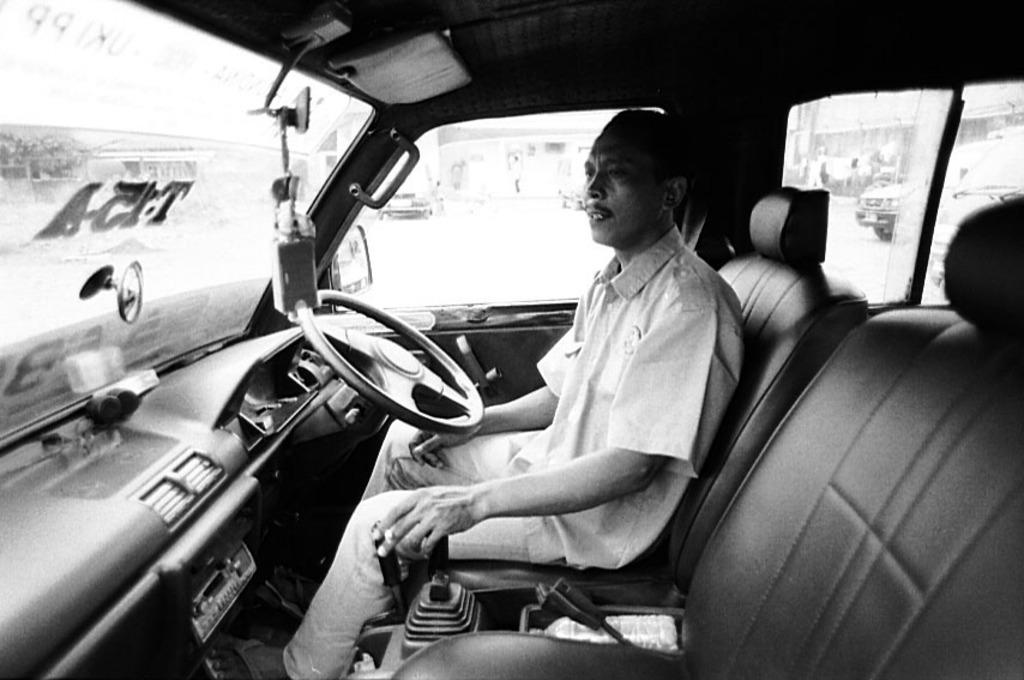What is the color scheme of the image? The image is black and white. What is the person inside the car doing? The person is sitting inside the car and holding a gear. What can be seen in the car besides the person? There is a steering wheel visible in the car. What feature allows the person to see outside the car? There are windows in the car. Is there a stream visible outside the car during the rainstorm in the image? There is no stream or rainstorm present in the image; it is a black and white image of a person sitting inside a car. 